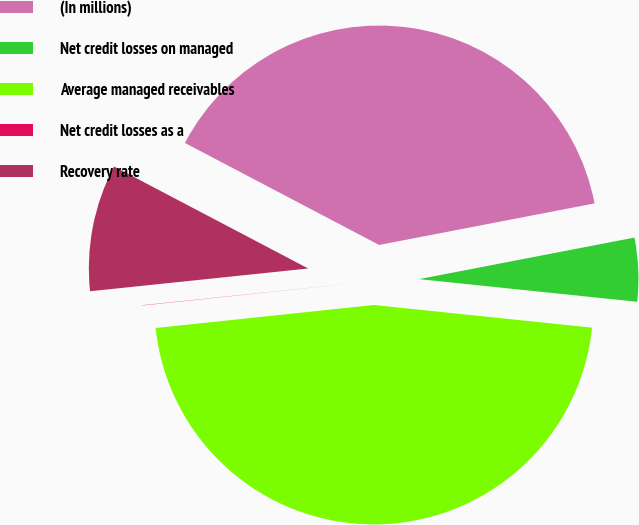Convert chart to OTSL. <chart><loc_0><loc_0><loc_500><loc_500><pie_chart><fcel>(In millions)<fcel>Net credit losses on managed<fcel>Average managed receivables<fcel>Net credit losses as a<fcel>Recovery rate<nl><fcel>39.27%<fcel>4.68%<fcel>46.68%<fcel>0.02%<fcel>9.35%<nl></chart> 